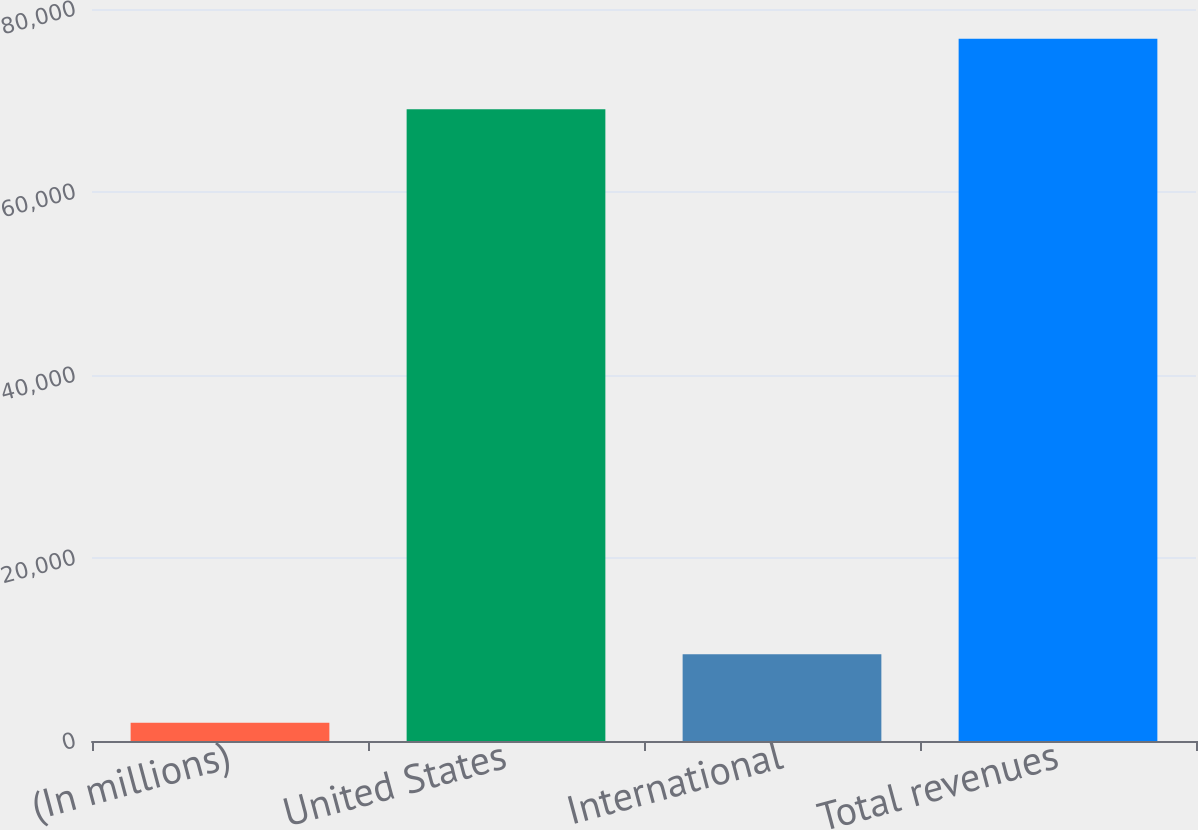Convert chart to OTSL. <chart><loc_0><loc_0><loc_500><loc_500><bar_chart><fcel>(In millions)<fcel>United States<fcel>International<fcel>Total revenues<nl><fcel>2008<fcel>69034<fcel>9482.6<fcel>76754<nl></chart> 